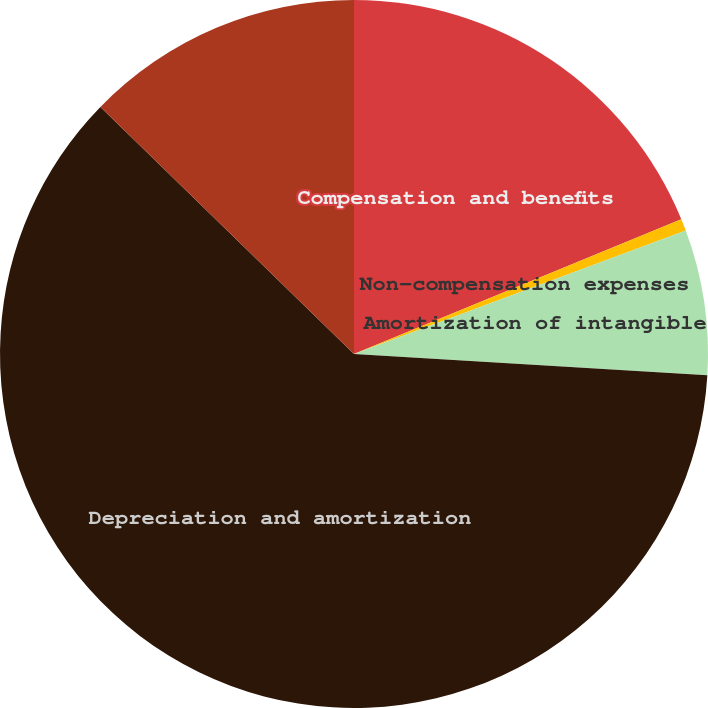Convert chart. <chart><loc_0><loc_0><loc_500><loc_500><pie_chart><fcel>Compensation and benefits<fcel>Non-compensation expenses<fcel>Amortization of intangible<fcel>Depreciation and amortization<fcel>Total operating expenses<nl><fcel>18.78%<fcel>0.55%<fcel>6.63%<fcel>61.33%<fcel>12.71%<nl></chart> 